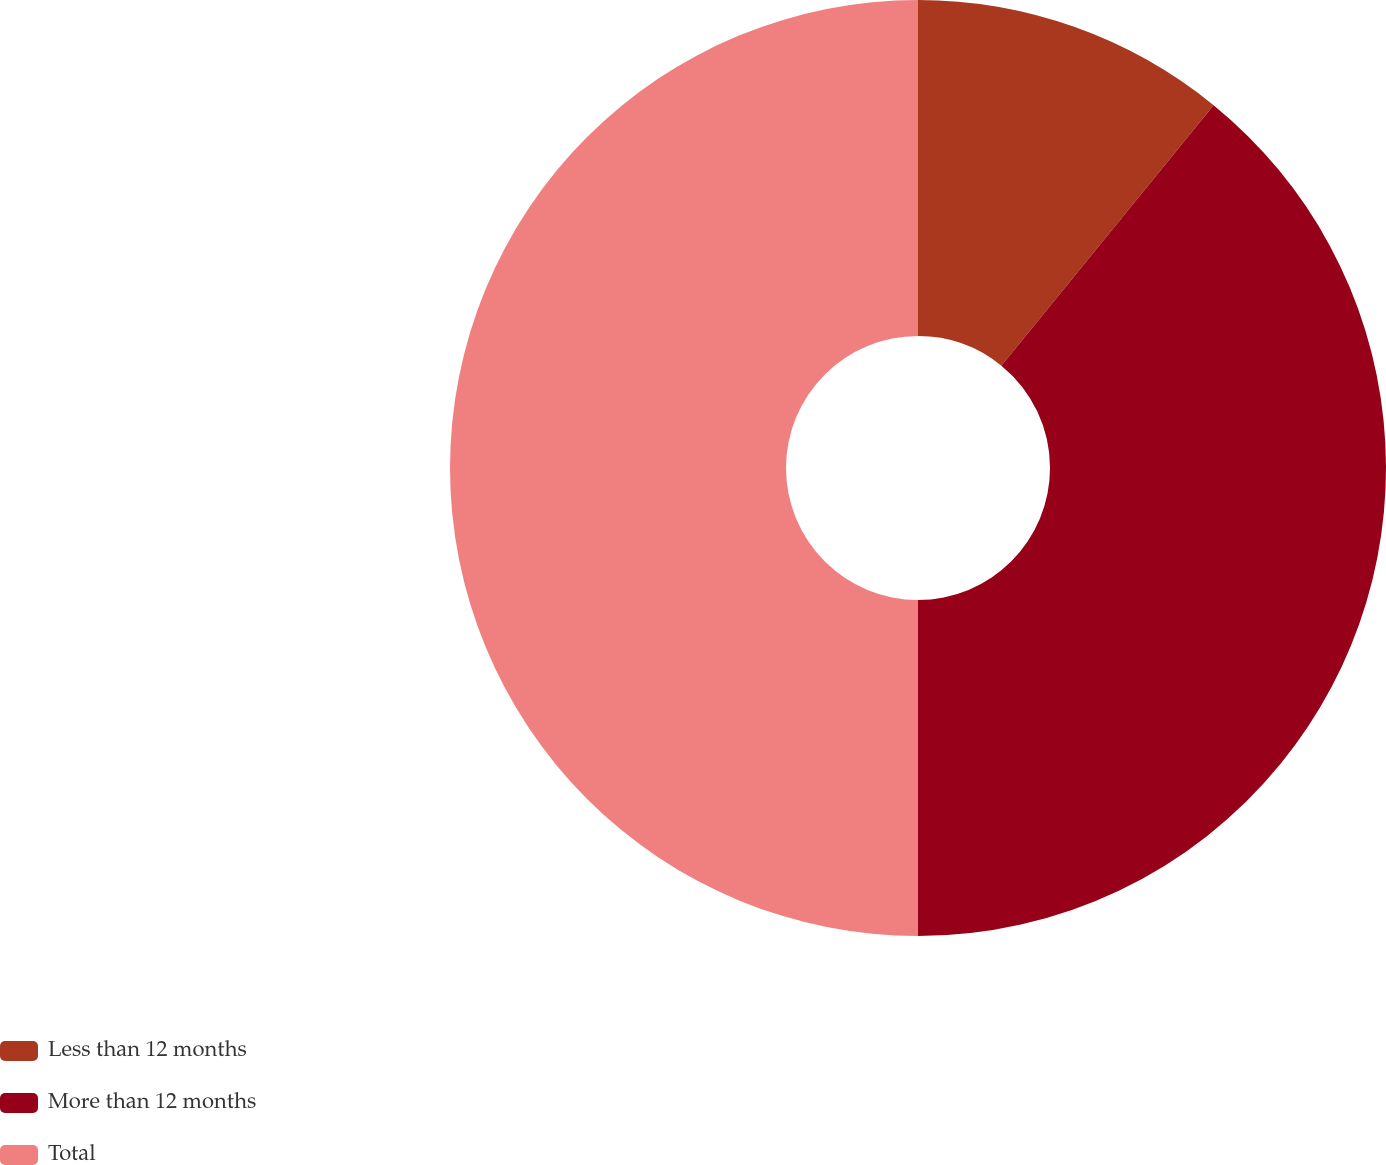Convert chart to OTSL. <chart><loc_0><loc_0><loc_500><loc_500><pie_chart><fcel>Less than 12 months<fcel>More than 12 months<fcel>Total<nl><fcel>10.88%<fcel>39.12%<fcel>50.0%<nl></chart> 